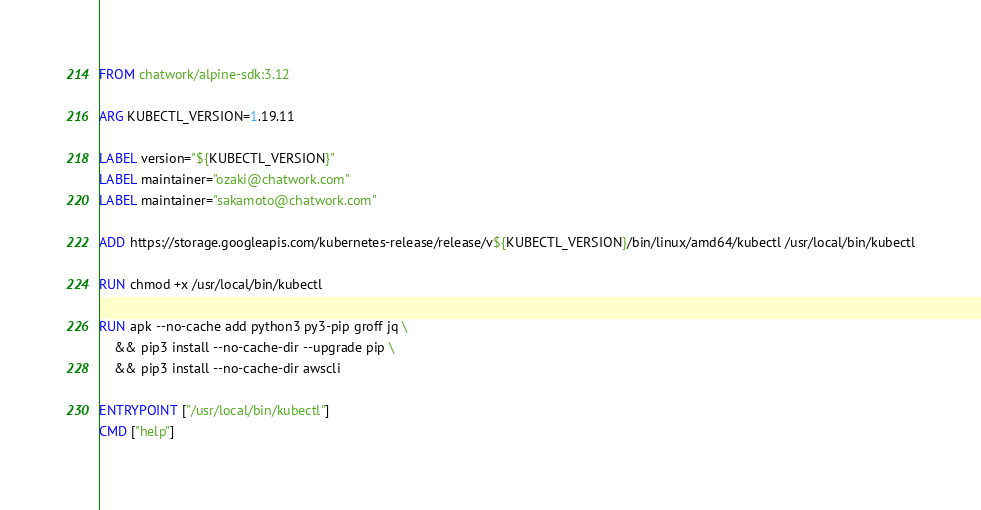Convert code to text. <code><loc_0><loc_0><loc_500><loc_500><_Dockerfile_>FROM chatwork/alpine-sdk:3.12

ARG KUBECTL_VERSION=1.19.11

LABEL version="${KUBECTL_VERSION}"
LABEL maintainer="ozaki@chatwork.com"
LABEL maintainer="sakamoto@chatwork.com"

ADD https://storage.googleapis.com/kubernetes-release/release/v${KUBECTL_VERSION}/bin/linux/amd64/kubectl /usr/local/bin/kubectl

RUN chmod +x /usr/local/bin/kubectl

RUN apk --no-cache add python3 py3-pip groff jq \
    && pip3 install --no-cache-dir --upgrade pip \
    && pip3 install --no-cache-dir awscli

ENTRYPOINT ["/usr/local/bin/kubectl"]
CMD ["help"]
</code> 